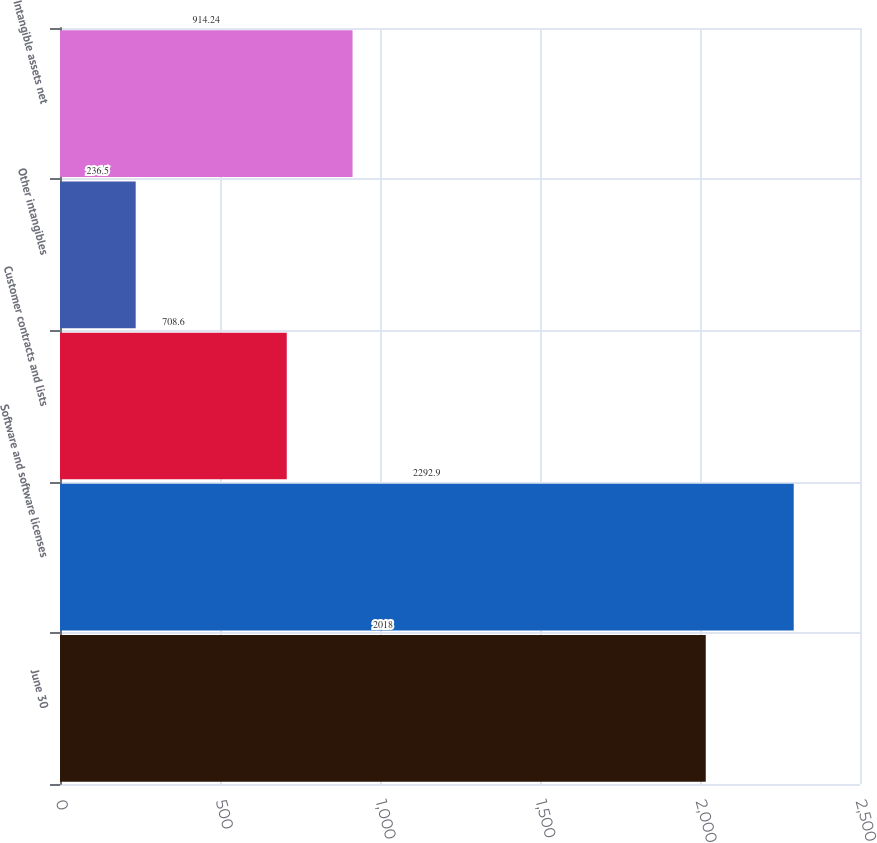Convert chart to OTSL. <chart><loc_0><loc_0><loc_500><loc_500><bar_chart><fcel>June 30<fcel>Software and software licenses<fcel>Customer contracts and lists<fcel>Other intangibles<fcel>Intangible assets net<nl><fcel>2018<fcel>2292.9<fcel>708.6<fcel>236.5<fcel>914.24<nl></chart> 